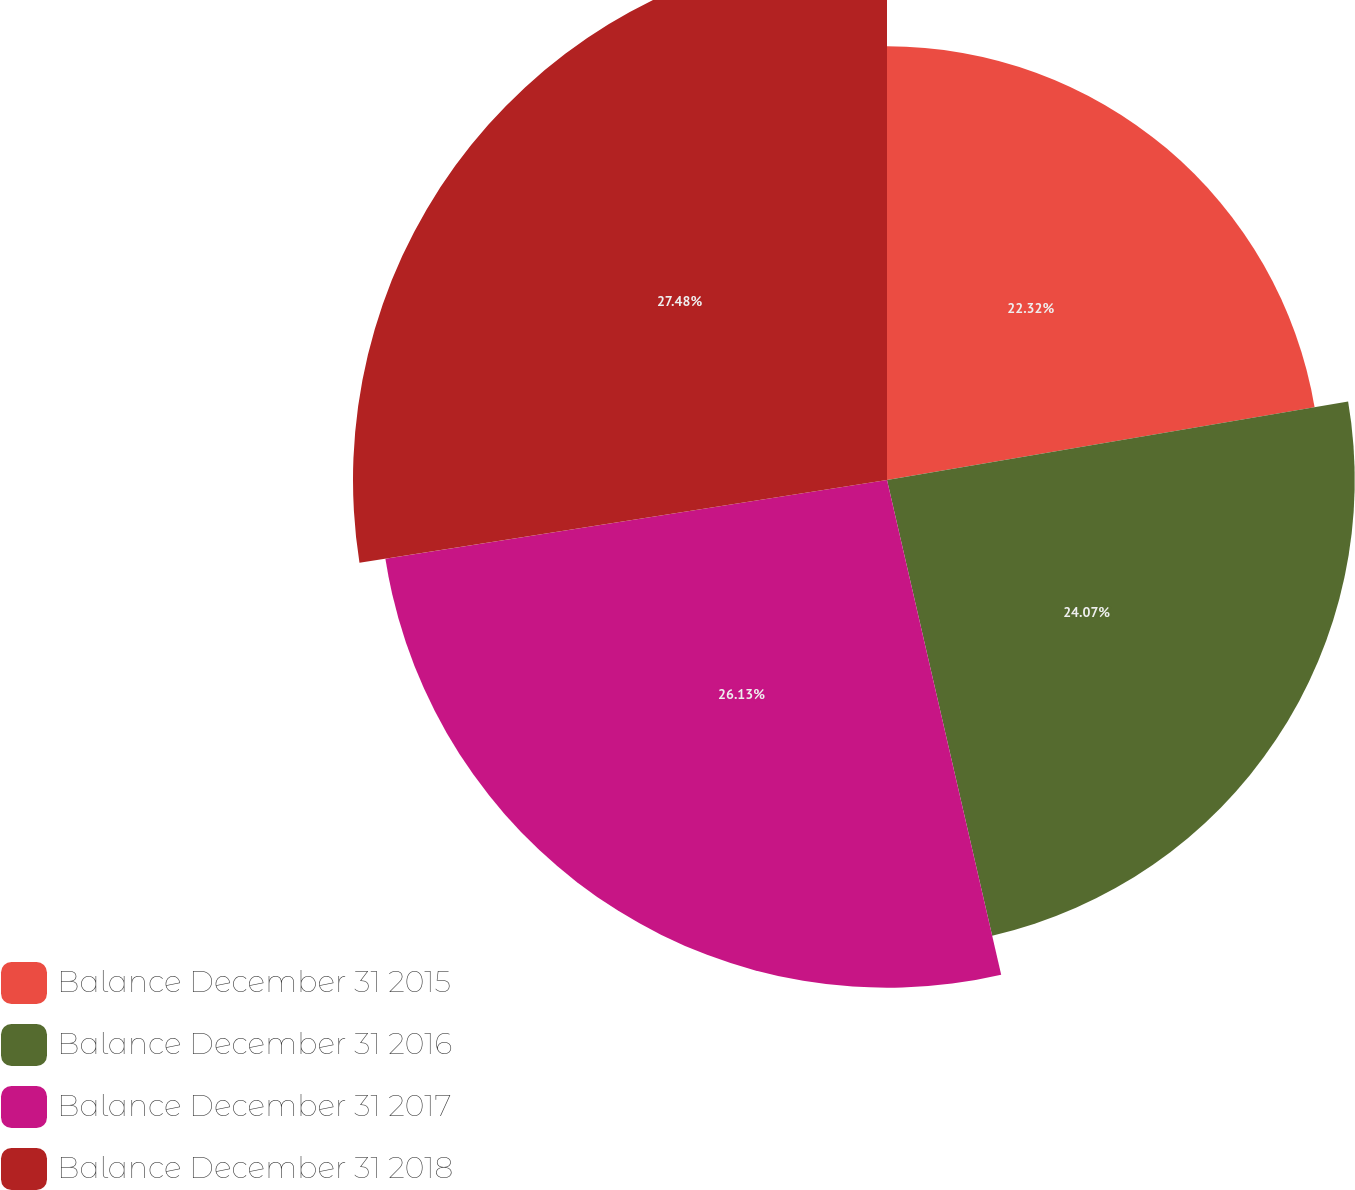<chart> <loc_0><loc_0><loc_500><loc_500><pie_chart><fcel>Balance December 31 2015<fcel>Balance December 31 2016<fcel>Balance December 31 2017<fcel>Balance December 31 2018<nl><fcel>22.32%<fcel>24.07%<fcel>26.13%<fcel>27.48%<nl></chart> 